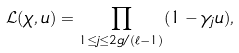<formula> <loc_0><loc_0><loc_500><loc_500>\mathcal { L } ( \chi , u ) = \prod _ { 1 \leq j \leq 2 g / ( \ell - 1 ) } ( 1 - \gamma _ { j } u ) ,</formula> 